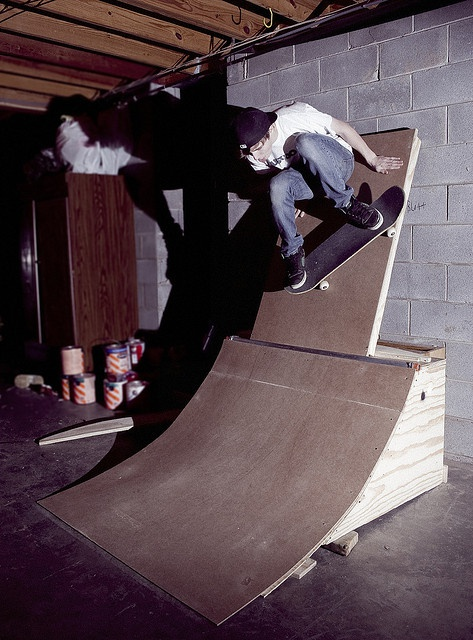Describe the objects in this image and their specific colors. I can see people in black, lightgray, darkgray, and gray tones and skateboard in black, purple, and gray tones in this image. 